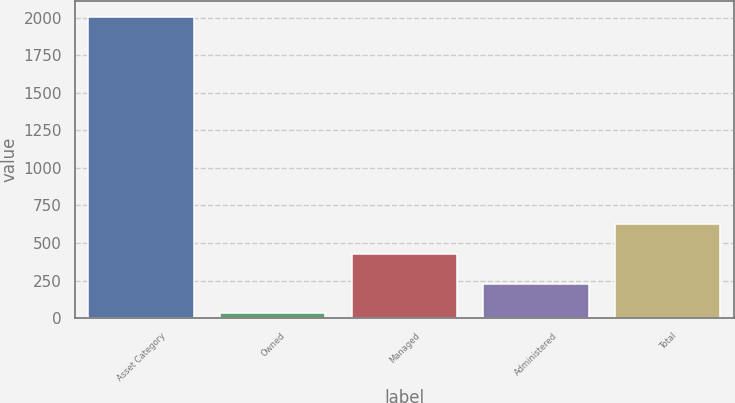Convert chart. <chart><loc_0><loc_0><loc_500><loc_500><bar_chart><fcel>Asset Category<fcel>Owned<fcel>Managed<fcel>Administered<fcel>Total<nl><fcel>2008<fcel>31.7<fcel>426.96<fcel>229.33<fcel>624.59<nl></chart> 